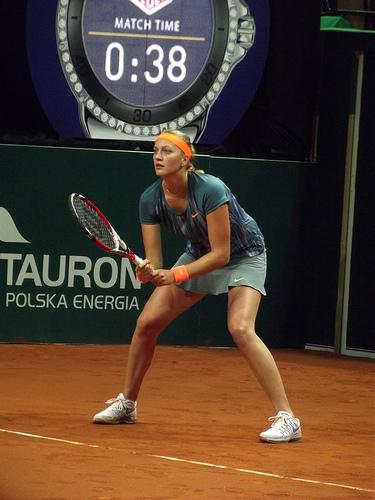Identify the person in the image and describe their attire and accessories. A blond female athlete wearing a gray Nike athletic shirt, gray skirt, white sneakers, an orange headband, and an orange wristband. Briefly describe the person and their actions in the image. A woman in a gray outfit, white sneakers, and orange headband is playing tennis with a red and white racket. Comment on the general sport and the specific equipment being used in the image. The image showcases tennis as the sport, with a woman holding a red and white tennis racket while wearing white sneakers. Describe the main event occurring in the image and any background objects. A blond female athlete plays tennis on a brown court with white lines, green barriers, and a large digital billboard nearby. Mention the key activities happening in the image. A woman wearing a grey tennis outfit and orange headband is playing tennis on a court, holding a red and white racket. Describe the key color combinations present in the image. The image features a woman wearing a gray dress, white shoes, and an orange headband, holding a red and white tennis racket. Mention the primary object in the image and describe its activity. A woman playing tennis, dressed in grey outfit, is holding a red and white tennis racket while wearing a bright orange headband. Talk about the major elements and their colors found in the image. The image features a woman playing tennis in grey attire, white sneakers, orange headband and wristband, and a red and white racket. Provide a general description of the scene captured in the image. A blond female athlete in a gray tennis outfit and an orange headband is playing tennis on a court with white lines. Describe the ground and surroundings in which the woman is playing the sport. Playing tennis on a brown ground with white lines, the woman is near a green barrier and a large digital billboard. 